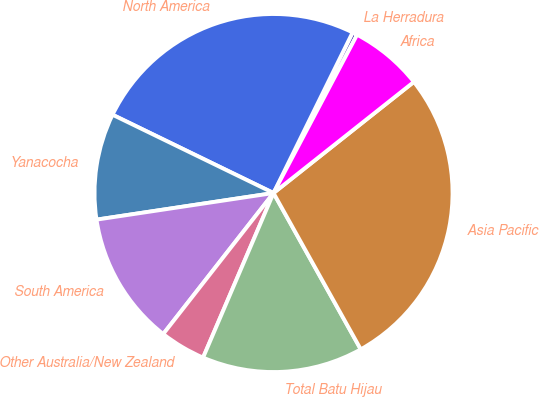<chart> <loc_0><loc_0><loc_500><loc_500><pie_chart><fcel>La Herradura<fcel>North America<fcel>Yanacocha<fcel>South America<fcel>Other Australia/New Zealand<fcel>Total Batu Hijau<fcel>Asia Pacific<fcel>Africa<nl><fcel>0.45%<fcel>25.08%<fcel>9.58%<fcel>12.06%<fcel>4.13%<fcel>14.54%<fcel>27.56%<fcel>6.61%<nl></chart> 